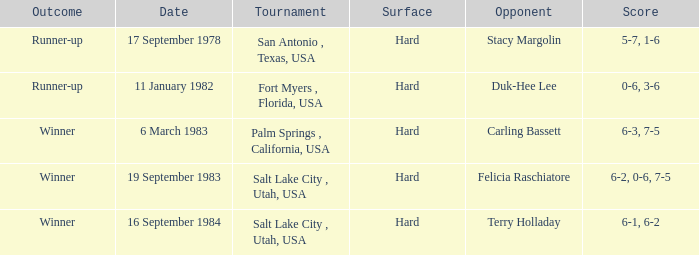Who was the opponent for the match were the outcome was runner-up and the score was 5-7, 1-6? Stacy Margolin. 